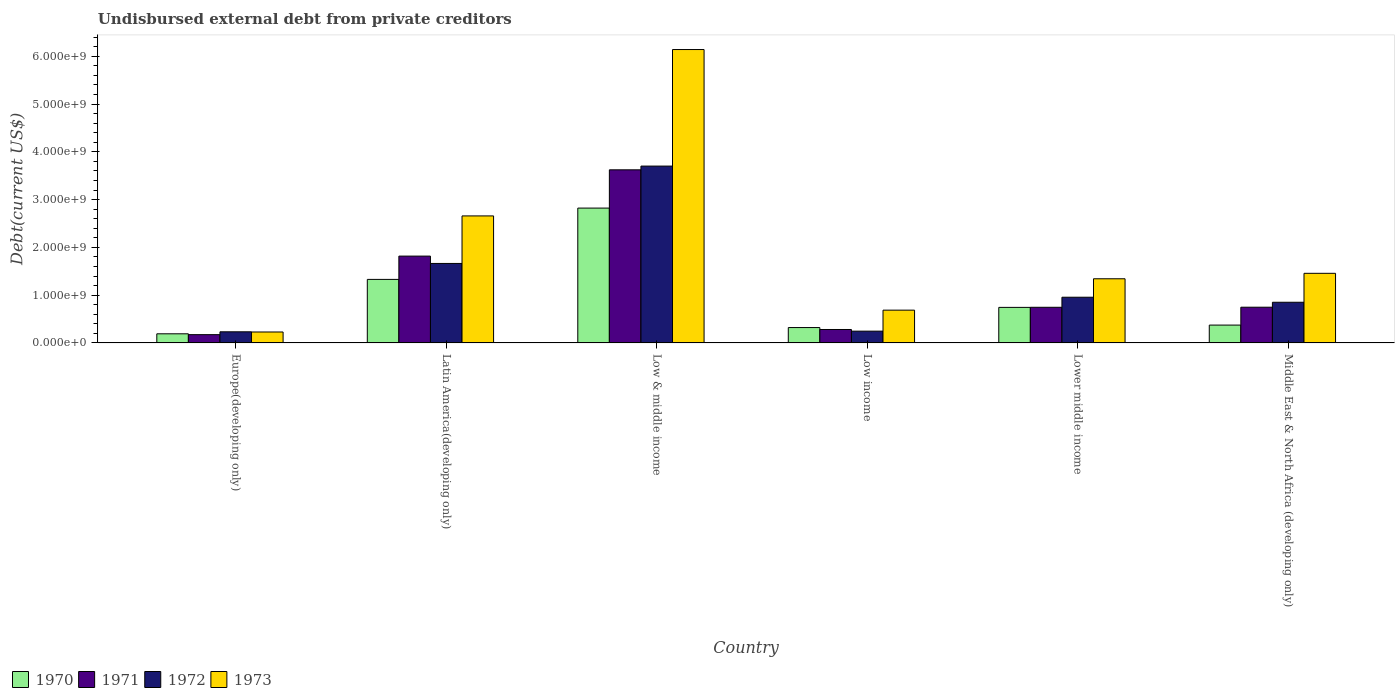Are the number of bars per tick equal to the number of legend labels?
Give a very brief answer. Yes. Are the number of bars on each tick of the X-axis equal?
Make the answer very short. Yes. What is the label of the 6th group of bars from the left?
Keep it short and to the point. Middle East & North Africa (developing only). In how many cases, is the number of bars for a given country not equal to the number of legend labels?
Your response must be concise. 0. What is the total debt in 1970 in Low & middle income?
Give a very brief answer. 2.82e+09. Across all countries, what is the maximum total debt in 1970?
Offer a very short reply. 2.82e+09. Across all countries, what is the minimum total debt in 1971?
Make the answer very short. 1.74e+08. In which country was the total debt in 1970 minimum?
Offer a terse response. Europe(developing only). What is the total total debt in 1970 in the graph?
Provide a succinct answer. 5.78e+09. What is the difference between the total debt in 1972 in Lower middle income and that in Middle East & North Africa (developing only)?
Offer a very short reply. 1.05e+08. What is the difference between the total debt in 1970 in Latin America(developing only) and the total debt in 1971 in Europe(developing only)?
Make the answer very short. 1.16e+09. What is the average total debt in 1970 per country?
Make the answer very short. 9.64e+08. What is the difference between the total debt of/in 1973 and total debt of/in 1971 in Low & middle income?
Provide a succinct answer. 2.52e+09. What is the ratio of the total debt in 1970 in Low income to that in Lower middle income?
Provide a succinct answer. 0.43. Is the total debt in 1970 in Low income less than that in Lower middle income?
Provide a short and direct response. Yes. Is the difference between the total debt in 1973 in Low income and Lower middle income greater than the difference between the total debt in 1971 in Low income and Lower middle income?
Keep it short and to the point. No. What is the difference between the highest and the second highest total debt in 1973?
Ensure brevity in your answer.  -1.20e+09. What is the difference between the highest and the lowest total debt in 1970?
Your response must be concise. 2.63e+09. Is the sum of the total debt in 1973 in Low & middle income and Low income greater than the maximum total debt in 1972 across all countries?
Your answer should be compact. Yes. Is it the case that in every country, the sum of the total debt in 1973 and total debt in 1970 is greater than the sum of total debt in 1971 and total debt in 1972?
Your response must be concise. No. What does the 3rd bar from the left in Lower middle income represents?
Offer a terse response. 1972. Are all the bars in the graph horizontal?
Your answer should be compact. No. What is the difference between two consecutive major ticks on the Y-axis?
Your answer should be very brief. 1.00e+09. Does the graph contain grids?
Keep it short and to the point. No. Where does the legend appear in the graph?
Your response must be concise. Bottom left. How many legend labels are there?
Keep it short and to the point. 4. What is the title of the graph?
Provide a short and direct response. Undisbursed external debt from private creditors. What is the label or title of the X-axis?
Your answer should be very brief. Country. What is the label or title of the Y-axis?
Ensure brevity in your answer.  Debt(current US$). What is the Debt(current US$) of 1970 in Europe(developing only)?
Ensure brevity in your answer.  1.91e+08. What is the Debt(current US$) of 1971 in Europe(developing only)?
Your response must be concise. 1.74e+08. What is the Debt(current US$) in 1972 in Europe(developing only)?
Provide a succinct answer. 2.33e+08. What is the Debt(current US$) in 1973 in Europe(developing only)?
Offer a terse response. 2.29e+08. What is the Debt(current US$) in 1970 in Latin America(developing only)?
Provide a succinct answer. 1.33e+09. What is the Debt(current US$) of 1971 in Latin America(developing only)?
Give a very brief answer. 1.82e+09. What is the Debt(current US$) of 1972 in Latin America(developing only)?
Keep it short and to the point. 1.66e+09. What is the Debt(current US$) of 1973 in Latin America(developing only)?
Provide a succinct answer. 2.66e+09. What is the Debt(current US$) in 1970 in Low & middle income?
Offer a very short reply. 2.82e+09. What is the Debt(current US$) of 1971 in Low & middle income?
Your answer should be compact. 3.62e+09. What is the Debt(current US$) of 1972 in Low & middle income?
Your answer should be very brief. 3.70e+09. What is the Debt(current US$) in 1973 in Low & middle income?
Give a very brief answer. 6.14e+09. What is the Debt(current US$) of 1970 in Low income?
Ensure brevity in your answer.  3.22e+08. What is the Debt(current US$) in 1971 in Low income?
Give a very brief answer. 2.82e+08. What is the Debt(current US$) of 1972 in Low income?
Offer a very short reply. 2.47e+08. What is the Debt(current US$) of 1973 in Low income?
Provide a succinct answer. 6.86e+08. What is the Debt(current US$) of 1970 in Lower middle income?
Your answer should be compact. 7.44e+08. What is the Debt(current US$) of 1971 in Lower middle income?
Give a very brief answer. 7.46e+08. What is the Debt(current US$) of 1972 in Lower middle income?
Your response must be concise. 9.57e+08. What is the Debt(current US$) in 1973 in Lower middle income?
Your response must be concise. 1.34e+09. What is the Debt(current US$) of 1970 in Middle East & North Africa (developing only)?
Make the answer very short. 3.74e+08. What is the Debt(current US$) of 1971 in Middle East & North Africa (developing only)?
Offer a very short reply. 7.48e+08. What is the Debt(current US$) of 1972 in Middle East & North Africa (developing only)?
Your answer should be compact. 8.51e+08. What is the Debt(current US$) of 1973 in Middle East & North Africa (developing only)?
Your answer should be compact. 1.46e+09. Across all countries, what is the maximum Debt(current US$) of 1970?
Your answer should be compact. 2.82e+09. Across all countries, what is the maximum Debt(current US$) of 1971?
Make the answer very short. 3.62e+09. Across all countries, what is the maximum Debt(current US$) in 1972?
Offer a very short reply. 3.70e+09. Across all countries, what is the maximum Debt(current US$) of 1973?
Offer a terse response. 6.14e+09. Across all countries, what is the minimum Debt(current US$) in 1970?
Your response must be concise. 1.91e+08. Across all countries, what is the minimum Debt(current US$) of 1971?
Give a very brief answer. 1.74e+08. Across all countries, what is the minimum Debt(current US$) in 1972?
Make the answer very short. 2.33e+08. Across all countries, what is the minimum Debt(current US$) of 1973?
Ensure brevity in your answer.  2.29e+08. What is the total Debt(current US$) in 1970 in the graph?
Your answer should be compact. 5.78e+09. What is the total Debt(current US$) in 1971 in the graph?
Your answer should be very brief. 7.39e+09. What is the total Debt(current US$) in 1972 in the graph?
Make the answer very short. 7.65e+09. What is the total Debt(current US$) in 1973 in the graph?
Provide a short and direct response. 1.25e+1. What is the difference between the Debt(current US$) of 1970 in Europe(developing only) and that in Latin America(developing only)?
Your answer should be compact. -1.14e+09. What is the difference between the Debt(current US$) of 1971 in Europe(developing only) and that in Latin America(developing only)?
Keep it short and to the point. -1.64e+09. What is the difference between the Debt(current US$) in 1972 in Europe(developing only) and that in Latin America(developing only)?
Make the answer very short. -1.43e+09. What is the difference between the Debt(current US$) in 1973 in Europe(developing only) and that in Latin America(developing only)?
Give a very brief answer. -2.43e+09. What is the difference between the Debt(current US$) of 1970 in Europe(developing only) and that in Low & middle income?
Ensure brevity in your answer.  -2.63e+09. What is the difference between the Debt(current US$) in 1971 in Europe(developing only) and that in Low & middle income?
Your answer should be compact. -3.45e+09. What is the difference between the Debt(current US$) in 1972 in Europe(developing only) and that in Low & middle income?
Your response must be concise. -3.47e+09. What is the difference between the Debt(current US$) in 1973 in Europe(developing only) and that in Low & middle income?
Your response must be concise. -5.91e+09. What is the difference between the Debt(current US$) in 1970 in Europe(developing only) and that in Low income?
Provide a short and direct response. -1.31e+08. What is the difference between the Debt(current US$) in 1971 in Europe(developing only) and that in Low income?
Offer a very short reply. -1.08e+08. What is the difference between the Debt(current US$) in 1972 in Europe(developing only) and that in Low income?
Your answer should be compact. -1.39e+07. What is the difference between the Debt(current US$) in 1973 in Europe(developing only) and that in Low income?
Provide a succinct answer. -4.57e+08. What is the difference between the Debt(current US$) in 1970 in Europe(developing only) and that in Lower middle income?
Make the answer very short. -5.53e+08. What is the difference between the Debt(current US$) in 1971 in Europe(developing only) and that in Lower middle income?
Your response must be concise. -5.73e+08. What is the difference between the Debt(current US$) of 1972 in Europe(developing only) and that in Lower middle income?
Make the answer very short. -7.24e+08. What is the difference between the Debt(current US$) of 1973 in Europe(developing only) and that in Lower middle income?
Give a very brief answer. -1.11e+09. What is the difference between the Debt(current US$) of 1970 in Europe(developing only) and that in Middle East & North Africa (developing only)?
Give a very brief answer. -1.83e+08. What is the difference between the Debt(current US$) in 1971 in Europe(developing only) and that in Middle East & North Africa (developing only)?
Your answer should be very brief. -5.74e+08. What is the difference between the Debt(current US$) in 1972 in Europe(developing only) and that in Middle East & North Africa (developing only)?
Your answer should be compact. -6.18e+08. What is the difference between the Debt(current US$) of 1973 in Europe(developing only) and that in Middle East & North Africa (developing only)?
Provide a succinct answer. -1.23e+09. What is the difference between the Debt(current US$) of 1970 in Latin America(developing only) and that in Low & middle income?
Provide a succinct answer. -1.49e+09. What is the difference between the Debt(current US$) of 1971 in Latin America(developing only) and that in Low & middle income?
Make the answer very short. -1.81e+09. What is the difference between the Debt(current US$) of 1972 in Latin America(developing only) and that in Low & middle income?
Offer a very short reply. -2.04e+09. What is the difference between the Debt(current US$) in 1973 in Latin America(developing only) and that in Low & middle income?
Offer a terse response. -3.48e+09. What is the difference between the Debt(current US$) of 1970 in Latin America(developing only) and that in Low income?
Provide a succinct answer. 1.01e+09. What is the difference between the Debt(current US$) in 1971 in Latin America(developing only) and that in Low income?
Offer a very short reply. 1.54e+09. What is the difference between the Debt(current US$) in 1972 in Latin America(developing only) and that in Low income?
Provide a succinct answer. 1.42e+09. What is the difference between the Debt(current US$) of 1973 in Latin America(developing only) and that in Low income?
Make the answer very short. 1.97e+09. What is the difference between the Debt(current US$) of 1970 in Latin America(developing only) and that in Lower middle income?
Keep it short and to the point. 5.86e+08. What is the difference between the Debt(current US$) in 1971 in Latin America(developing only) and that in Lower middle income?
Your answer should be very brief. 1.07e+09. What is the difference between the Debt(current US$) of 1972 in Latin America(developing only) and that in Lower middle income?
Your answer should be compact. 7.07e+08. What is the difference between the Debt(current US$) of 1973 in Latin America(developing only) and that in Lower middle income?
Keep it short and to the point. 1.32e+09. What is the difference between the Debt(current US$) in 1970 in Latin America(developing only) and that in Middle East & North Africa (developing only)?
Ensure brevity in your answer.  9.56e+08. What is the difference between the Debt(current US$) of 1971 in Latin America(developing only) and that in Middle East & North Africa (developing only)?
Your answer should be compact. 1.07e+09. What is the difference between the Debt(current US$) in 1972 in Latin America(developing only) and that in Middle East & North Africa (developing only)?
Your answer should be compact. 8.12e+08. What is the difference between the Debt(current US$) of 1973 in Latin America(developing only) and that in Middle East & North Africa (developing only)?
Your response must be concise. 1.20e+09. What is the difference between the Debt(current US$) of 1970 in Low & middle income and that in Low income?
Your answer should be compact. 2.50e+09. What is the difference between the Debt(current US$) in 1971 in Low & middle income and that in Low income?
Offer a very short reply. 3.34e+09. What is the difference between the Debt(current US$) in 1972 in Low & middle income and that in Low income?
Your answer should be compact. 3.45e+09. What is the difference between the Debt(current US$) in 1973 in Low & middle income and that in Low income?
Your response must be concise. 5.45e+09. What is the difference between the Debt(current US$) of 1970 in Low & middle income and that in Lower middle income?
Your response must be concise. 2.08e+09. What is the difference between the Debt(current US$) of 1971 in Low & middle income and that in Lower middle income?
Offer a terse response. 2.88e+09. What is the difference between the Debt(current US$) in 1972 in Low & middle income and that in Lower middle income?
Offer a terse response. 2.74e+09. What is the difference between the Debt(current US$) of 1973 in Low & middle income and that in Lower middle income?
Ensure brevity in your answer.  4.80e+09. What is the difference between the Debt(current US$) of 1970 in Low & middle income and that in Middle East & North Africa (developing only)?
Provide a succinct answer. 2.45e+09. What is the difference between the Debt(current US$) in 1971 in Low & middle income and that in Middle East & North Africa (developing only)?
Offer a very short reply. 2.88e+09. What is the difference between the Debt(current US$) of 1972 in Low & middle income and that in Middle East & North Africa (developing only)?
Provide a succinct answer. 2.85e+09. What is the difference between the Debt(current US$) of 1973 in Low & middle income and that in Middle East & North Africa (developing only)?
Make the answer very short. 4.68e+09. What is the difference between the Debt(current US$) in 1970 in Low income and that in Lower middle income?
Your response must be concise. -4.22e+08. What is the difference between the Debt(current US$) of 1971 in Low income and that in Lower middle income?
Keep it short and to the point. -4.65e+08. What is the difference between the Debt(current US$) in 1972 in Low income and that in Lower middle income?
Your answer should be very brief. -7.10e+08. What is the difference between the Debt(current US$) of 1973 in Low income and that in Lower middle income?
Provide a succinct answer. -6.56e+08. What is the difference between the Debt(current US$) of 1970 in Low income and that in Middle East & North Africa (developing only)?
Provide a short and direct response. -5.15e+07. What is the difference between the Debt(current US$) in 1971 in Low income and that in Middle East & North Africa (developing only)?
Keep it short and to the point. -4.66e+08. What is the difference between the Debt(current US$) of 1972 in Low income and that in Middle East & North Africa (developing only)?
Make the answer very short. -6.05e+08. What is the difference between the Debt(current US$) in 1973 in Low income and that in Middle East & North Africa (developing only)?
Keep it short and to the point. -7.71e+08. What is the difference between the Debt(current US$) in 1970 in Lower middle income and that in Middle East & North Africa (developing only)?
Provide a short and direct response. 3.71e+08. What is the difference between the Debt(current US$) in 1971 in Lower middle income and that in Middle East & North Africa (developing only)?
Keep it short and to the point. -1.62e+06. What is the difference between the Debt(current US$) in 1972 in Lower middle income and that in Middle East & North Africa (developing only)?
Ensure brevity in your answer.  1.05e+08. What is the difference between the Debt(current US$) of 1973 in Lower middle income and that in Middle East & North Africa (developing only)?
Ensure brevity in your answer.  -1.14e+08. What is the difference between the Debt(current US$) of 1970 in Europe(developing only) and the Debt(current US$) of 1971 in Latin America(developing only)?
Your answer should be compact. -1.63e+09. What is the difference between the Debt(current US$) of 1970 in Europe(developing only) and the Debt(current US$) of 1972 in Latin America(developing only)?
Provide a succinct answer. -1.47e+09. What is the difference between the Debt(current US$) of 1970 in Europe(developing only) and the Debt(current US$) of 1973 in Latin America(developing only)?
Keep it short and to the point. -2.47e+09. What is the difference between the Debt(current US$) in 1971 in Europe(developing only) and the Debt(current US$) in 1972 in Latin America(developing only)?
Keep it short and to the point. -1.49e+09. What is the difference between the Debt(current US$) of 1971 in Europe(developing only) and the Debt(current US$) of 1973 in Latin America(developing only)?
Offer a very short reply. -2.48e+09. What is the difference between the Debt(current US$) of 1972 in Europe(developing only) and the Debt(current US$) of 1973 in Latin America(developing only)?
Your response must be concise. -2.43e+09. What is the difference between the Debt(current US$) of 1970 in Europe(developing only) and the Debt(current US$) of 1971 in Low & middle income?
Your response must be concise. -3.43e+09. What is the difference between the Debt(current US$) in 1970 in Europe(developing only) and the Debt(current US$) in 1972 in Low & middle income?
Make the answer very short. -3.51e+09. What is the difference between the Debt(current US$) in 1970 in Europe(developing only) and the Debt(current US$) in 1973 in Low & middle income?
Your response must be concise. -5.95e+09. What is the difference between the Debt(current US$) in 1971 in Europe(developing only) and the Debt(current US$) in 1972 in Low & middle income?
Offer a very short reply. -3.53e+09. What is the difference between the Debt(current US$) in 1971 in Europe(developing only) and the Debt(current US$) in 1973 in Low & middle income?
Ensure brevity in your answer.  -5.97e+09. What is the difference between the Debt(current US$) in 1972 in Europe(developing only) and the Debt(current US$) in 1973 in Low & middle income?
Offer a terse response. -5.91e+09. What is the difference between the Debt(current US$) of 1970 in Europe(developing only) and the Debt(current US$) of 1971 in Low income?
Give a very brief answer. -9.05e+07. What is the difference between the Debt(current US$) of 1970 in Europe(developing only) and the Debt(current US$) of 1972 in Low income?
Give a very brief answer. -5.58e+07. What is the difference between the Debt(current US$) in 1970 in Europe(developing only) and the Debt(current US$) in 1973 in Low income?
Offer a very short reply. -4.95e+08. What is the difference between the Debt(current US$) in 1971 in Europe(developing only) and the Debt(current US$) in 1972 in Low income?
Your answer should be compact. -7.31e+07. What is the difference between the Debt(current US$) in 1971 in Europe(developing only) and the Debt(current US$) in 1973 in Low income?
Your answer should be very brief. -5.13e+08. What is the difference between the Debt(current US$) in 1972 in Europe(developing only) and the Debt(current US$) in 1973 in Low income?
Your answer should be compact. -4.54e+08. What is the difference between the Debt(current US$) in 1970 in Europe(developing only) and the Debt(current US$) in 1971 in Lower middle income?
Your response must be concise. -5.55e+08. What is the difference between the Debt(current US$) in 1970 in Europe(developing only) and the Debt(current US$) in 1972 in Lower middle income?
Provide a succinct answer. -7.66e+08. What is the difference between the Debt(current US$) of 1970 in Europe(developing only) and the Debt(current US$) of 1973 in Lower middle income?
Provide a succinct answer. -1.15e+09. What is the difference between the Debt(current US$) in 1971 in Europe(developing only) and the Debt(current US$) in 1972 in Lower middle income?
Offer a terse response. -7.83e+08. What is the difference between the Debt(current US$) of 1971 in Europe(developing only) and the Debt(current US$) of 1973 in Lower middle income?
Your response must be concise. -1.17e+09. What is the difference between the Debt(current US$) of 1972 in Europe(developing only) and the Debt(current US$) of 1973 in Lower middle income?
Provide a succinct answer. -1.11e+09. What is the difference between the Debt(current US$) in 1970 in Europe(developing only) and the Debt(current US$) in 1971 in Middle East & North Africa (developing only)?
Ensure brevity in your answer.  -5.57e+08. What is the difference between the Debt(current US$) in 1970 in Europe(developing only) and the Debt(current US$) in 1972 in Middle East & North Africa (developing only)?
Your answer should be compact. -6.60e+08. What is the difference between the Debt(current US$) in 1970 in Europe(developing only) and the Debt(current US$) in 1973 in Middle East & North Africa (developing only)?
Keep it short and to the point. -1.27e+09. What is the difference between the Debt(current US$) of 1971 in Europe(developing only) and the Debt(current US$) of 1972 in Middle East & North Africa (developing only)?
Give a very brief answer. -6.78e+08. What is the difference between the Debt(current US$) of 1971 in Europe(developing only) and the Debt(current US$) of 1973 in Middle East & North Africa (developing only)?
Your response must be concise. -1.28e+09. What is the difference between the Debt(current US$) in 1972 in Europe(developing only) and the Debt(current US$) in 1973 in Middle East & North Africa (developing only)?
Provide a short and direct response. -1.22e+09. What is the difference between the Debt(current US$) of 1970 in Latin America(developing only) and the Debt(current US$) of 1971 in Low & middle income?
Your answer should be very brief. -2.29e+09. What is the difference between the Debt(current US$) of 1970 in Latin America(developing only) and the Debt(current US$) of 1972 in Low & middle income?
Offer a terse response. -2.37e+09. What is the difference between the Debt(current US$) in 1970 in Latin America(developing only) and the Debt(current US$) in 1973 in Low & middle income?
Provide a succinct answer. -4.81e+09. What is the difference between the Debt(current US$) of 1971 in Latin America(developing only) and the Debt(current US$) of 1972 in Low & middle income?
Your answer should be compact. -1.88e+09. What is the difference between the Debt(current US$) in 1971 in Latin America(developing only) and the Debt(current US$) in 1973 in Low & middle income?
Keep it short and to the point. -4.32e+09. What is the difference between the Debt(current US$) of 1972 in Latin America(developing only) and the Debt(current US$) of 1973 in Low & middle income?
Provide a succinct answer. -4.48e+09. What is the difference between the Debt(current US$) in 1970 in Latin America(developing only) and the Debt(current US$) in 1971 in Low income?
Your answer should be compact. 1.05e+09. What is the difference between the Debt(current US$) of 1970 in Latin America(developing only) and the Debt(current US$) of 1972 in Low income?
Your response must be concise. 1.08e+09. What is the difference between the Debt(current US$) of 1970 in Latin America(developing only) and the Debt(current US$) of 1973 in Low income?
Provide a succinct answer. 6.43e+08. What is the difference between the Debt(current US$) in 1971 in Latin America(developing only) and the Debt(current US$) in 1972 in Low income?
Provide a short and direct response. 1.57e+09. What is the difference between the Debt(current US$) in 1971 in Latin America(developing only) and the Debt(current US$) in 1973 in Low income?
Make the answer very short. 1.13e+09. What is the difference between the Debt(current US$) of 1972 in Latin America(developing only) and the Debt(current US$) of 1973 in Low income?
Offer a very short reply. 9.77e+08. What is the difference between the Debt(current US$) in 1970 in Latin America(developing only) and the Debt(current US$) in 1971 in Lower middle income?
Keep it short and to the point. 5.84e+08. What is the difference between the Debt(current US$) of 1970 in Latin America(developing only) and the Debt(current US$) of 1972 in Lower middle income?
Provide a short and direct response. 3.73e+08. What is the difference between the Debt(current US$) of 1970 in Latin America(developing only) and the Debt(current US$) of 1973 in Lower middle income?
Ensure brevity in your answer.  -1.29e+07. What is the difference between the Debt(current US$) of 1971 in Latin America(developing only) and the Debt(current US$) of 1972 in Lower middle income?
Your answer should be compact. 8.61e+08. What is the difference between the Debt(current US$) of 1971 in Latin America(developing only) and the Debt(current US$) of 1973 in Lower middle income?
Keep it short and to the point. 4.75e+08. What is the difference between the Debt(current US$) in 1972 in Latin America(developing only) and the Debt(current US$) in 1973 in Lower middle income?
Provide a succinct answer. 3.21e+08. What is the difference between the Debt(current US$) of 1970 in Latin America(developing only) and the Debt(current US$) of 1971 in Middle East & North Africa (developing only)?
Offer a terse response. 5.82e+08. What is the difference between the Debt(current US$) of 1970 in Latin America(developing only) and the Debt(current US$) of 1972 in Middle East & North Africa (developing only)?
Provide a short and direct response. 4.79e+08. What is the difference between the Debt(current US$) in 1970 in Latin America(developing only) and the Debt(current US$) in 1973 in Middle East & North Africa (developing only)?
Keep it short and to the point. -1.27e+08. What is the difference between the Debt(current US$) in 1971 in Latin America(developing only) and the Debt(current US$) in 1972 in Middle East & North Africa (developing only)?
Ensure brevity in your answer.  9.66e+08. What is the difference between the Debt(current US$) of 1971 in Latin America(developing only) and the Debt(current US$) of 1973 in Middle East & North Africa (developing only)?
Give a very brief answer. 3.61e+08. What is the difference between the Debt(current US$) in 1972 in Latin America(developing only) and the Debt(current US$) in 1973 in Middle East & North Africa (developing only)?
Keep it short and to the point. 2.07e+08. What is the difference between the Debt(current US$) in 1970 in Low & middle income and the Debt(current US$) in 1971 in Low income?
Provide a short and direct response. 2.54e+09. What is the difference between the Debt(current US$) in 1970 in Low & middle income and the Debt(current US$) in 1972 in Low income?
Your response must be concise. 2.58e+09. What is the difference between the Debt(current US$) in 1970 in Low & middle income and the Debt(current US$) in 1973 in Low income?
Make the answer very short. 2.14e+09. What is the difference between the Debt(current US$) in 1971 in Low & middle income and the Debt(current US$) in 1972 in Low income?
Give a very brief answer. 3.38e+09. What is the difference between the Debt(current US$) of 1971 in Low & middle income and the Debt(current US$) of 1973 in Low income?
Offer a terse response. 2.94e+09. What is the difference between the Debt(current US$) of 1972 in Low & middle income and the Debt(current US$) of 1973 in Low income?
Offer a terse response. 3.02e+09. What is the difference between the Debt(current US$) in 1970 in Low & middle income and the Debt(current US$) in 1971 in Lower middle income?
Offer a terse response. 2.08e+09. What is the difference between the Debt(current US$) of 1970 in Low & middle income and the Debt(current US$) of 1972 in Lower middle income?
Provide a short and direct response. 1.87e+09. What is the difference between the Debt(current US$) in 1970 in Low & middle income and the Debt(current US$) in 1973 in Lower middle income?
Provide a short and direct response. 1.48e+09. What is the difference between the Debt(current US$) of 1971 in Low & middle income and the Debt(current US$) of 1972 in Lower middle income?
Provide a short and direct response. 2.67e+09. What is the difference between the Debt(current US$) in 1971 in Low & middle income and the Debt(current US$) in 1973 in Lower middle income?
Make the answer very short. 2.28e+09. What is the difference between the Debt(current US$) of 1972 in Low & middle income and the Debt(current US$) of 1973 in Lower middle income?
Give a very brief answer. 2.36e+09. What is the difference between the Debt(current US$) of 1970 in Low & middle income and the Debt(current US$) of 1971 in Middle East & North Africa (developing only)?
Give a very brief answer. 2.07e+09. What is the difference between the Debt(current US$) in 1970 in Low & middle income and the Debt(current US$) in 1972 in Middle East & North Africa (developing only)?
Your response must be concise. 1.97e+09. What is the difference between the Debt(current US$) in 1970 in Low & middle income and the Debt(current US$) in 1973 in Middle East & North Africa (developing only)?
Give a very brief answer. 1.37e+09. What is the difference between the Debt(current US$) in 1971 in Low & middle income and the Debt(current US$) in 1972 in Middle East & North Africa (developing only)?
Provide a succinct answer. 2.77e+09. What is the difference between the Debt(current US$) of 1971 in Low & middle income and the Debt(current US$) of 1973 in Middle East & North Africa (developing only)?
Offer a terse response. 2.17e+09. What is the difference between the Debt(current US$) in 1972 in Low & middle income and the Debt(current US$) in 1973 in Middle East & North Africa (developing only)?
Offer a very short reply. 2.24e+09. What is the difference between the Debt(current US$) of 1970 in Low income and the Debt(current US$) of 1971 in Lower middle income?
Provide a succinct answer. -4.24e+08. What is the difference between the Debt(current US$) of 1970 in Low income and the Debt(current US$) of 1972 in Lower middle income?
Make the answer very short. -6.35e+08. What is the difference between the Debt(current US$) of 1970 in Low income and the Debt(current US$) of 1973 in Lower middle income?
Your response must be concise. -1.02e+09. What is the difference between the Debt(current US$) in 1971 in Low income and the Debt(current US$) in 1972 in Lower middle income?
Your answer should be very brief. -6.75e+08. What is the difference between the Debt(current US$) in 1971 in Low income and the Debt(current US$) in 1973 in Lower middle income?
Your answer should be very brief. -1.06e+09. What is the difference between the Debt(current US$) of 1972 in Low income and the Debt(current US$) of 1973 in Lower middle income?
Make the answer very short. -1.10e+09. What is the difference between the Debt(current US$) in 1970 in Low income and the Debt(current US$) in 1971 in Middle East & North Africa (developing only)?
Your response must be concise. -4.26e+08. What is the difference between the Debt(current US$) in 1970 in Low income and the Debt(current US$) in 1972 in Middle East & North Africa (developing only)?
Offer a terse response. -5.29e+08. What is the difference between the Debt(current US$) in 1970 in Low income and the Debt(current US$) in 1973 in Middle East & North Africa (developing only)?
Keep it short and to the point. -1.13e+09. What is the difference between the Debt(current US$) in 1971 in Low income and the Debt(current US$) in 1972 in Middle East & North Africa (developing only)?
Your response must be concise. -5.70e+08. What is the difference between the Debt(current US$) of 1971 in Low income and the Debt(current US$) of 1973 in Middle East & North Africa (developing only)?
Offer a terse response. -1.18e+09. What is the difference between the Debt(current US$) of 1972 in Low income and the Debt(current US$) of 1973 in Middle East & North Africa (developing only)?
Your response must be concise. -1.21e+09. What is the difference between the Debt(current US$) of 1970 in Lower middle income and the Debt(current US$) of 1971 in Middle East & North Africa (developing only)?
Provide a succinct answer. -3.71e+06. What is the difference between the Debt(current US$) in 1970 in Lower middle income and the Debt(current US$) in 1972 in Middle East & North Africa (developing only)?
Ensure brevity in your answer.  -1.07e+08. What is the difference between the Debt(current US$) in 1970 in Lower middle income and the Debt(current US$) in 1973 in Middle East & North Africa (developing only)?
Offer a very short reply. -7.13e+08. What is the difference between the Debt(current US$) of 1971 in Lower middle income and the Debt(current US$) of 1972 in Middle East & North Africa (developing only)?
Your answer should be very brief. -1.05e+08. What is the difference between the Debt(current US$) in 1971 in Lower middle income and the Debt(current US$) in 1973 in Middle East & North Africa (developing only)?
Keep it short and to the point. -7.11e+08. What is the difference between the Debt(current US$) in 1972 in Lower middle income and the Debt(current US$) in 1973 in Middle East & North Africa (developing only)?
Offer a terse response. -5.00e+08. What is the average Debt(current US$) in 1970 per country?
Give a very brief answer. 9.64e+08. What is the average Debt(current US$) of 1971 per country?
Offer a terse response. 1.23e+09. What is the average Debt(current US$) of 1972 per country?
Give a very brief answer. 1.28e+09. What is the average Debt(current US$) in 1973 per country?
Give a very brief answer. 2.09e+09. What is the difference between the Debt(current US$) of 1970 and Debt(current US$) of 1971 in Europe(developing only)?
Your response must be concise. 1.74e+07. What is the difference between the Debt(current US$) of 1970 and Debt(current US$) of 1972 in Europe(developing only)?
Your answer should be compact. -4.19e+07. What is the difference between the Debt(current US$) in 1970 and Debt(current US$) in 1973 in Europe(developing only)?
Offer a very short reply. -3.81e+07. What is the difference between the Debt(current US$) of 1971 and Debt(current US$) of 1972 in Europe(developing only)?
Your response must be concise. -5.92e+07. What is the difference between the Debt(current US$) of 1971 and Debt(current US$) of 1973 in Europe(developing only)?
Keep it short and to the point. -5.55e+07. What is the difference between the Debt(current US$) of 1972 and Debt(current US$) of 1973 in Europe(developing only)?
Give a very brief answer. 3.73e+06. What is the difference between the Debt(current US$) in 1970 and Debt(current US$) in 1971 in Latin America(developing only)?
Offer a very short reply. -4.88e+08. What is the difference between the Debt(current US$) of 1970 and Debt(current US$) of 1972 in Latin America(developing only)?
Keep it short and to the point. -3.34e+08. What is the difference between the Debt(current US$) in 1970 and Debt(current US$) in 1973 in Latin America(developing only)?
Ensure brevity in your answer.  -1.33e+09. What is the difference between the Debt(current US$) of 1971 and Debt(current US$) of 1972 in Latin America(developing only)?
Provide a short and direct response. 1.54e+08. What is the difference between the Debt(current US$) of 1971 and Debt(current US$) of 1973 in Latin America(developing only)?
Offer a very short reply. -8.41e+08. What is the difference between the Debt(current US$) in 1972 and Debt(current US$) in 1973 in Latin America(developing only)?
Offer a terse response. -9.95e+08. What is the difference between the Debt(current US$) of 1970 and Debt(current US$) of 1971 in Low & middle income?
Your response must be concise. -8.01e+08. What is the difference between the Debt(current US$) of 1970 and Debt(current US$) of 1972 in Low & middle income?
Your answer should be very brief. -8.79e+08. What is the difference between the Debt(current US$) in 1970 and Debt(current US$) in 1973 in Low & middle income?
Keep it short and to the point. -3.32e+09. What is the difference between the Debt(current US$) in 1971 and Debt(current US$) in 1972 in Low & middle income?
Keep it short and to the point. -7.84e+07. What is the difference between the Debt(current US$) in 1971 and Debt(current US$) in 1973 in Low & middle income?
Make the answer very short. -2.52e+09. What is the difference between the Debt(current US$) in 1972 and Debt(current US$) in 1973 in Low & middle income?
Provide a succinct answer. -2.44e+09. What is the difference between the Debt(current US$) in 1970 and Debt(current US$) in 1971 in Low income?
Provide a short and direct response. 4.06e+07. What is the difference between the Debt(current US$) in 1970 and Debt(current US$) in 1972 in Low income?
Provide a short and direct response. 7.53e+07. What is the difference between the Debt(current US$) in 1970 and Debt(current US$) in 1973 in Low income?
Provide a short and direct response. -3.64e+08. What is the difference between the Debt(current US$) of 1971 and Debt(current US$) of 1972 in Low income?
Provide a succinct answer. 3.47e+07. What is the difference between the Debt(current US$) in 1971 and Debt(current US$) in 1973 in Low income?
Your answer should be compact. -4.05e+08. What is the difference between the Debt(current US$) in 1972 and Debt(current US$) in 1973 in Low income?
Provide a short and direct response. -4.40e+08. What is the difference between the Debt(current US$) in 1970 and Debt(current US$) in 1971 in Lower middle income?
Offer a very short reply. -2.10e+06. What is the difference between the Debt(current US$) of 1970 and Debt(current US$) of 1972 in Lower middle income?
Provide a short and direct response. -2.13e+08. What is the difference between the Debt(current US$) of 1970 and Debt(current US$) of 1973 in Lower middle income?
Provide a short and direct response. -5.99e+08. What is the difference between the Debt(current US$) of 1971 and Debt(current US$) of 1972 in Lower middle income?
Offer a very short reply. -2.11e+08. What is the difference between the Debt(current US$) in 1971 and Debt(current US$) in 1973 in Lower middle income?
Your response must be concise. -5.97e+08. What is the difference between the Debt(current US$) of 1972 and Debt(current US$) of 1973 in Lower middle income?
Offer a terse response. -3.86e+08. What is the difference between the Debt(current US$) in 1970 and Debt(current US$) in 1971 in Middle East & North Africa (developing only)?
Give a very brief answer. -3.74e+08. What is the difference between the Debt(current US$) of 1970 and Debt(current US$) of 1972 in Middle East & North Africa (developing only)?
Make the answer very short. -4.78e+08. What is the difference between the Debt(current US$) of 1970 and Debt(current US$) of 1973 in Middle East & North Africa (developing only)?
Give a very brief answer. -1.08e+09. What is the difference between the Debt(current US$) in 1971 and Debt(current US$) in 1972 in Middle East & North Africa (developing only)?
Make the answer very short. -1.04e+08. What is the difference between the Debt(current US$) of 1971 and Debt(current US$) of 1973 in Middle East & North Africa (developing only)?
Make the answer very short. -7.09e+08. What is the difference between the Debt(current US$) in 1972 and Debt(current US$) in 1973 in Middle East & North Africa (developing only)?
Give a very brief answer. -6.06e+08. What is the ratio of the Debt(current US$) of 1970 in Europe(developing only) to that in Latin America(developing only)?
Make the answer very short. 0.14. What is the ratio of the Debt(current US$) of 1971 in Europe(developing only) to that in Latin America(developing only)?
Give a very brief answer. 0.1. What is the ratio of the Debt(current US$) in 1972 in Europe(developing only) to that in Latin America(developing only)?
Make the answer very short. 0.14. What is the ratio of the Debt(current US$) in 1973 in Europe(developing only) to that in Latin America(developing only)?
Offer a very short reply. 0.09. What is the ratio of the Debt(current US$) in 1970 in Europe(developing only) to that in Low & middle income?
Provide a short and direct response. 0.07. What is the ratio of the Debt(current US$) of 1971 in Europe(developing only) to that in Low & middle income?
Make the answer very short. 0.05. What is the ratio of the Debt(current US$) of 1972 in Europe(developing only) to that in Low & middle income?
Make the answer very short. 0.06. What is the ratio of the Debt(current US$) in 1973 in Europe(developing only) to that in Low & middle income?
Keep it short and to the point. 0.04. What is the ratio of the Debt(current US$) of 1970 in Europe(developing only) to that in Low income?
Provide a succinct answer. 0.59. What is the ratio of the Debt(current US$) in 1971 in Europe(developing only) to that in Low income?
Your answer should be compact. 0.62. What is the ratio of the Debt(current US$) in 1972 in Europe(developing only) to that in Low income?
Your answer should be very brief. 0.94. What is the ratio of the Debt(current US$) in 1973 in Europe(developing only) to that in Low income?
Make the answer very short. 0.33. What is the ratio of the Debt(current US$) of 1970 in Europe(developing only) to that in Lower middle income?
Ensure brevity in your answer.  0.26. What is the ratio of the Debt(current US$) in 1971 in Europe(developing only) to that in Lower middle income?
Offer a terse response. 0.23. What is the ratio of the Debt(current US$) in 1972 in Europe(developing only) to that in Lower middle income?
Offer a terse response. 0.24. What is the ratio of the Debt(current US$) of 1973 in Europe(developing only) to that in Lower middle income?
Ensure brevity in your answer.  0.17. What is the ratio of the Debt(current US$) in 1970 in Europe(developing only) to that in Middle East & North Africa (developing only)?
Give a very brief answer. 0.51. What is the ratio of the Debt(current US$) in 1971 in Europe(developing only) to that in Middle East & North Africa (developing only)?
Offer a terse response. 0.23. What is the ratio of the Debt(current US$) of 1972 in Europe(developing only) to that in Middle East & North Africa (developing only)?
Make the answer very short. 0.27. What is the ratio of the Debt(current US$) in 1973 in Europe(developing only) to that in Middle East & North Africa (developing only)?
Ensure brevity in your answer.  0.16. What is the ratio of the Debt(current US$) in 1970 in Latin America(developing only) to that in Low & middle income?
Your answer should be very brief. 0.47. What is the ratio of the Debt(current US$) in 1971 in Latin America(developing only) to that in Low & middle income?
Your answer should be compact. 0.5. What is the ratio of the Debt(current US$) of 1972 in Latin America(developing only) to that in Low & middle income?
Keep it short and to the point. 0.45. What is the ratio of the Debt(current US$) of 1973 in Latin America(developing only) to that in Low & middle income?
Offer a terse response. 0.43. What is the ratio of the Debt(current US$) in 1970 in Latin America(developing only) to that in Low income?
Keep it short and to the point. 4.13. What is the ratio of the Debt(current US$) in 1971 in Latin America(developing only) to that in Low income?
Keep it short and to the point. 6.46. What is the ratio of the Debt(current US$) in 1972 in Latin America(developing only) to that in Low income?
Offer a terse response. 6.74. What is the ratio of the Debt(current US$) of 1973 in Latin America(developing only) to that in Low income?
Make the answer very short. 3.87. What is the ratio of the Debt(current US$) in 1970 in Latin America(developing only) to that in Lower middle income?
Offer a terse response. 1.79. What is the ratio of the Debt(current US$) of 1971 in Latin America(developing only) to that in Lower middle income?
Offer a terse response. 2.44. What is the ratio of the Debt(current US$) in 1972 in Latin America(developing only) to that in Lower middle income?
Give a very brief answer. 1.74. What is the ratio of the Debt(current US$) of 1973 in Latin America(developing only) to that in Lower middle income?
Your response must be concise. 1.98. What is the ratio of the Debt(current US$) of 1970 in Latin America(developing only) to that in Middle East & North Africa (developing only)?
Offer a terse response. 3.56. What is the ratio of the Debt(current US$) of 1971 in Latin America(developing only) to that in Middle East & North Africa (developing only)?
Give a very brief answer. 2.43. What is the ratio of the Debt(current US$) in 1972 in Latin America(developing only) to that in Middle East & North Africa (developing only)?
Give a very brief answer. 1.95. What is the ratio of the Debt(current US$) of 1973 in Latin America(developing only) to that in Middle East & North Africa (developing only)?
Keep it short and to the point. 1.82. What is the ratio of the Debt(current US$) in 1970 in Low & middle income to that in Low income?
Offer a terse response. 8.76. What is the ratio of the Debt(current US$) in 1971 in Low & middle income to that in Low income?
Your answer should be very brief. 12.87. What is the ratio of the Debt(current US$) of 1972 in Low & middle income to that in Low income?
Make the answer very short. 15. What is the ratio of the Debt(current US$) in 1973 in Low & middle income to that in Low income?
Your answer should be very brief. 8.95. What is the ratio of the Debt(current US$) in 1970 in Low & middle income to that in Lower middle income?
Offer a very short reply. 3.79. What is the ratio of the Debt(current US$) in 1971 in Low & middle income to that in Lower middle income?
Keep it short and to the point. 4.86. What is the ratio of the Debt(current US$) in 1972 in Low & middle income to that in Lower middle income?
Ensure brevity in your answer.  3.87. What is the ratio of the Debt(current US$) of 1973 in Low & middle income to that in Lower middle income?
Offer a terse response. 4.57. What is the ratio of the Debt(current US$) of 1970 in Low & middle income to that in Middle East & North Africa (developing only)?
Make the answer very short. 7.55. What is the ratio of the Debt(current US$) in 1971 in Low & middle income to that in Middle East & North Africa (developing only)?
Ensure brevity in your answer.  4.84. What is the ratio of the Debt(current US$) in 1972 in Low & middle income to that in Middle East & North Africa (developing only)?
Your response must be concise. 4.35. What is the ratio of the Debt(current US$) in 1973 in Low & middle income to that in Middle East & North Africa (developing only)?
Your answer should be very brief. 4.21. What is the ratio of the Debt(current US$) in 1970 in Low income to that in Lower middle income?
Give a very brief answer. 0.43. What is the ratio of the Debt(current US$) of 1971 in Low income to that in Lower middle income?
Offer a very short reply. 0.38. What is the ratio of the Debt(current US$) in 1972 in Low income to that in Lower middle income?
Give a very brief answer. 0.26. What is the ratio of the Debt(current US$) in 1973 in Low income to that in Lower middle income?
Give a very brief answer. 0.51. What is the ratio of the Debt(current US$) in 1970 in Low income to that in Middle East & North Africa (developing only)?
Make the answer very short. 0.86. What is the ratio of the Debt(current US$) in 1971 in Low income to that in Middle East & North Africa (developing only)?
Your response must be concise. 0.38. What is the ratio of the Debt(current US$) in 1972 in Low income to that in Middle East & North Africa (developing only)?
Provide a succinct answer. 0.29. What is the ratio of the Debt(current US$) in 1973 in Low income to that in Middle East & North Africa (developing only)?
Offer a very short reply. 0.47. What is the ratio of the Debt(current US$) of 1970 in Lower middle income to that in Middle East & North Africa (developing only)?
Offer a terse response. 1.99. What is the ratio of the Debt(current US$) in 1972 in Lower middle income to that in Middle East & North Africa (developing only)?
Offer a very short reply. 1.12. What is the ratio of the Debt(current US$) in 1973 in Lower middle income to that in Middle East & North Africa (developing only)?
Offer a terse response. 0.92. What is the difference between the highest and the second highest Debt(current US$) in 1970?
Offer a terse response. 1.49e+09. What is the difference between the highest and the second highest Debt(current US$) in 1971?
Provide a short and direct response. 1.81e+09. What is the difference between the highest and the second highest Debt(current US$) of 1972?
Provide a succinct answer. 2.04e+09. What is the difference between the highest and the second highest Debt(current US$) in 1973?
Your answer should be compact. 3.48e+09. What is the difference between the highest and the lowest Debt(current US$) of 1970?
Keep it short and to the point. 2.63e+09. What is the difference between the highest and the lowest Debt(current US$) of 1971?
Make the answer very short. 3.45e+09. What is the difference between the highest and the lowest Debt(current US$) of 1972?
Offer a very short reply. 3.47e+09. What is the difference between the highest and the lowest Debt(current US$) of 1973?
Your response must be concise. 5.91e+09. 